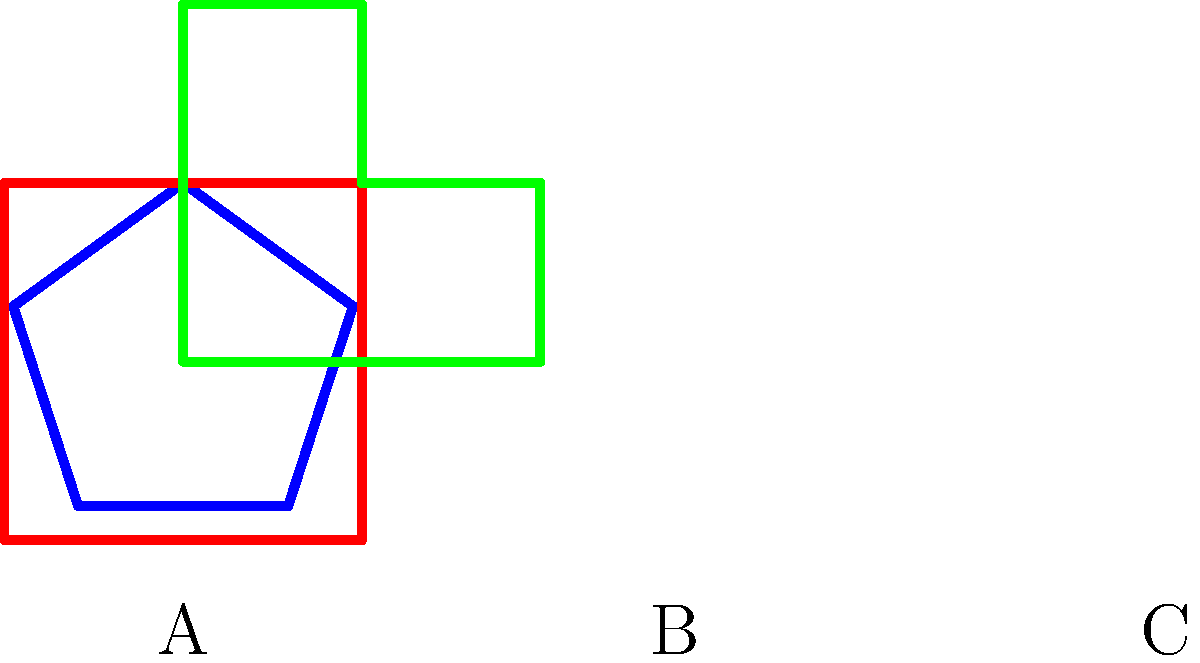Consider the three district shapes A, B, and C shown above. Which shape is most likely to represent a gerrymandered district, and why? To determine which district shape is most likely to represent gerrymandering, we need to consider the characteristics of gerrymandered districts:

1. Compactness: Gerrymandered districts often have irregular, non-compact shapes.
2. Contiguity: While all districts must be contiguous, gerrymandered ones may have unusual connections.
3. Equal population: All districts should have roughly equal populations, but this isn't visible from shape alone.

Analyzing each shape:

A. Pentagon: Regular, compact shape with equal sides.
B. Square: Simple, compact shape with equal sides.
C. Irregular shape: Non-compact, with protrusions and indentations.

Shape C exhibits characteristics most associated with gerrymandering:
1. Least compact of the three shapes.
2. Irregular boundaries that could indicate attempts to include or exclude specific populations.
3. The shape suggests possible "packing" or "cracking" of voters, common gerrymandering techniques.

Shapes A and B, being regular polygons, are less likely to represent gerrymandering as they don't show signs of manipulated boundaries to achieve political advantages.

Therefore, shape C is most likely to represent a gerrymandered district due to its irregular, non-compact form that could indicate intentional manipulation of district boundaries for political gain.
Answer: Shape C, due to its irregular, non-compact form suggesting possible boundary manipulation. 